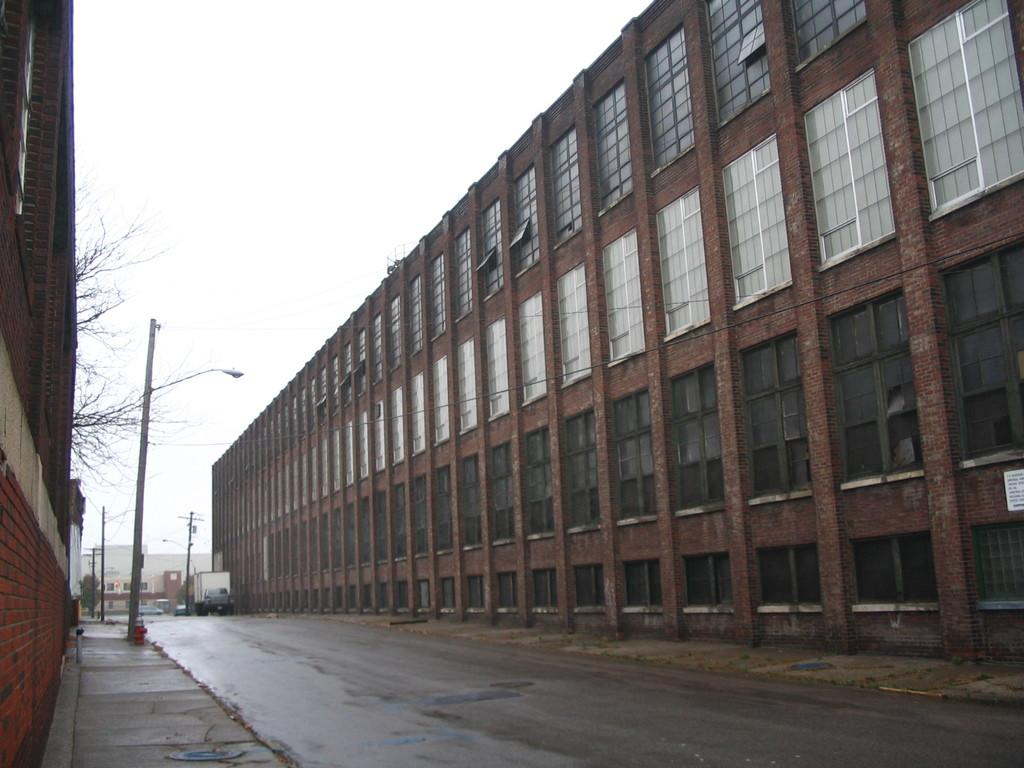What is the main feature of the image? There is a road in the image. What can be seen on either side of the road? Buildings are present on both sides of the road. What structures are visible along the road? Street light poles are visible in the image. What is the color of the sky in the image? The sky appears to be white in color. Is there a stream running alongside the road in the image? No, there is no stream present in the image. Can you see a lift in the image? No, there is no lift present in the image. 